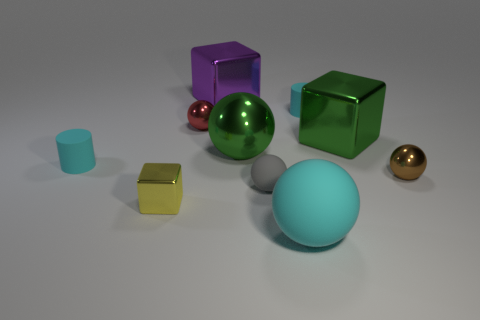Subtract all tiny blocks. How many blocks are left? 2 Subtract all cylinders. How many objects are left? 8 Subtract all small purple metallic objects. Subtract all brown objects. How many objects are left? 9 Add 9 green metallic balls. How many green metallic balls are left? 10 Add 8 tiny cyan matte things. How many tiny cyan matte things exist? 10 Subtract all yellow cubes. How many cubes are left? 2 Subtract 0 green cylinders. How many objects are left? 10 Subtract 2 spheres. How many spheres are left? 3 Subtract all gray cylinders. Subtract all red balls. How many cylinders are left? 2 Subtract all yellow cylinders. How many green cubes are left? 1 